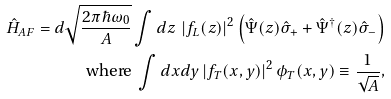Convert formula to latex. <formula><loc_0><loc_0><loc_500><loc_500>\hat { H } _ { A F } = d \sqrt { \frac { 2 \pi \hbar { \omega } _ { 0 } } { A } } \int d z \, \left | f _ { L } ( z ) \right | ^ { 2 } \left ( \hat { \Psi } ( z ) \hat { \sigma } _ { + } + \hat { \Psi } ^ { \dag } ( z ) \hat { \sigma } _ { - } \right ) \\ \text {where } \int d x d y \left | f _ { T } ( x , y ) \right | ^ { 2 } \phi _ { T } ( x , y ) \equiv \frac { 1 } { \sqrt { A } } ,</formula> 